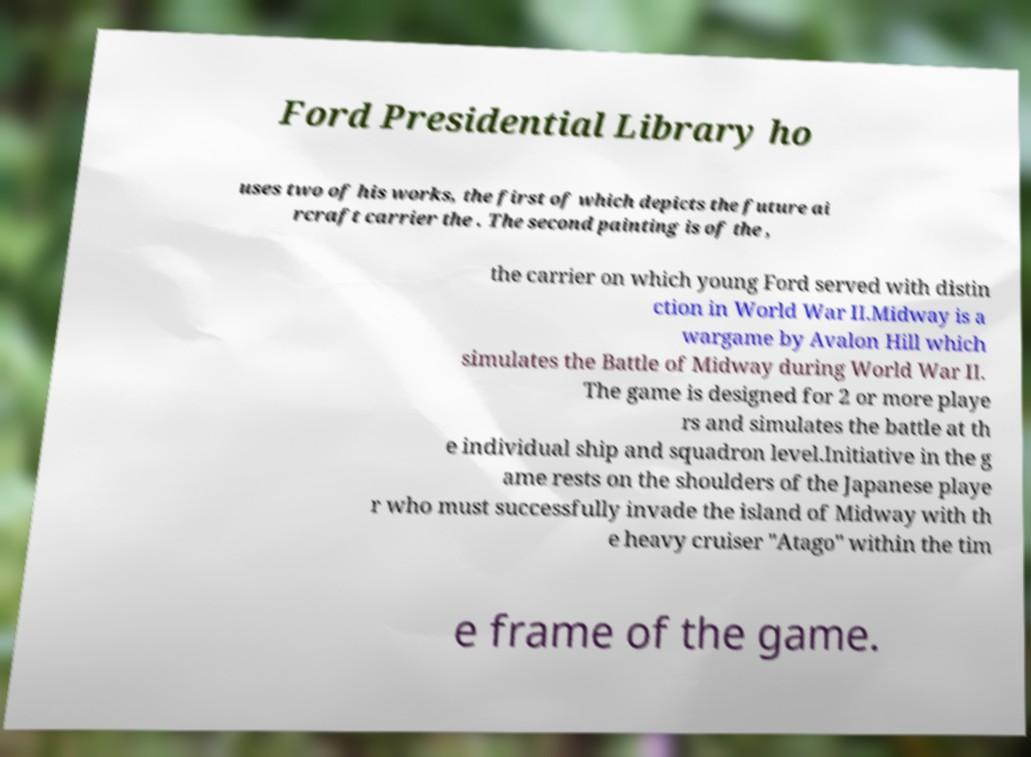I need the written content from this picture converted into text. Can you do that? Ford Presidential Library ho uses two of his works, the first of which depicts the future ai rcraft carrier the . The second painting is of the , the carrier on which young Ford served with distin ction in World War II.Midway is a wargame by Avalon Hill which simulates the Battle of Midway during World War II. The game is designed for 2 or more playe rs and simulates the battle at th e individual ship and squadron level.Initiative in the g ame rests on the shoulders of the Japanese playe r who must successfully invade the island of Midway with th e heavy cruiser "Atago" within the tim e frame of the game. 